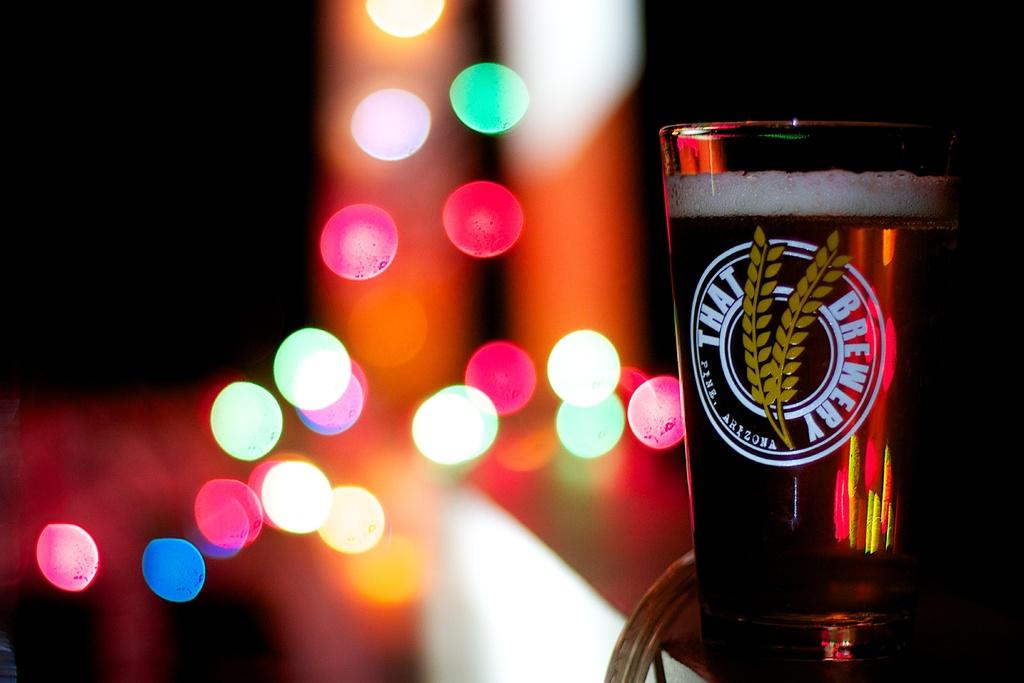<image>
Give a short and clear explanation of the subsequent image. a cup behind some lights that has a logo for 'that brewery' 